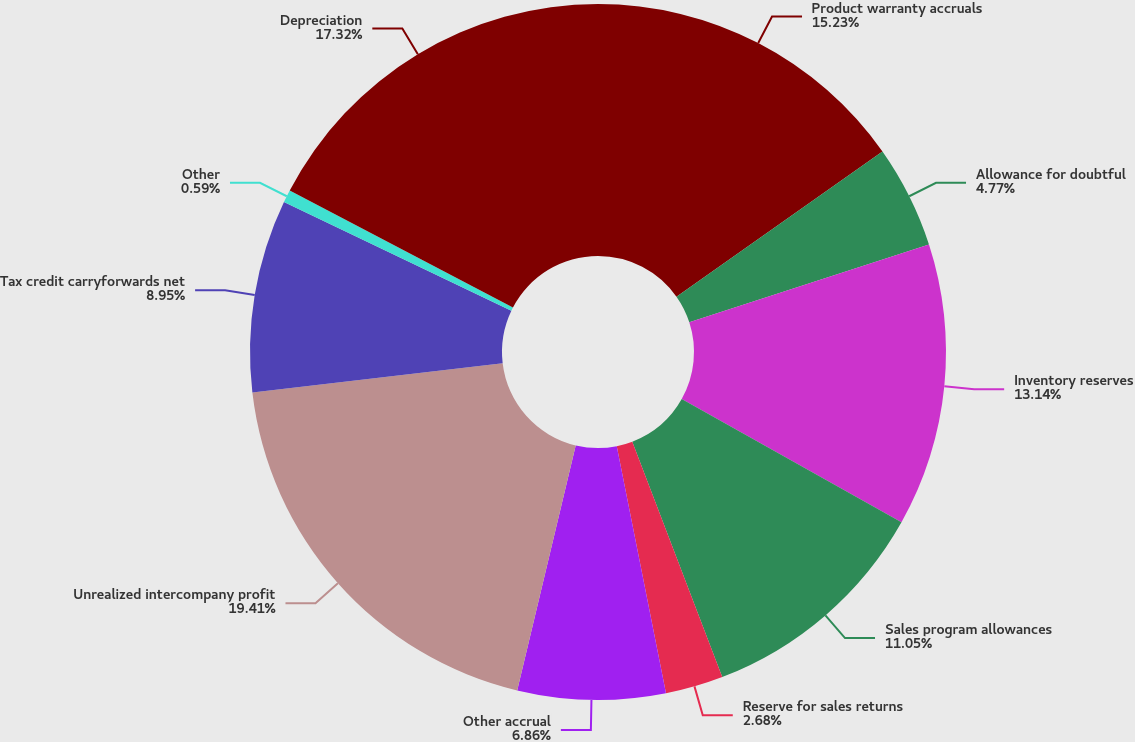Convert chart to OTSL. <chart><loc_0><loc_0><loc_500><loc_500><pie_chart><fcel>Product warranty accruals<fcel>Allowance for doubtful<fcel>Inventory reserves<fcel>Sales program allowances<fcel>Reserve for sales returns<fcel>Other accrual<fcel>Unrealized intercompany profit<fcel>Tax credit carryforwards net<fcel>Other<fcel>Depreciation<nl><fcel>15.23%<fcel>4.77%<fcel>13.14%<fcel>11.05%<fcel>2.68%<fcel>6.86%<fcel>19.41%<fcel>8.95%<fcel>0.59%<fcel>17.32%<nl></chart> 